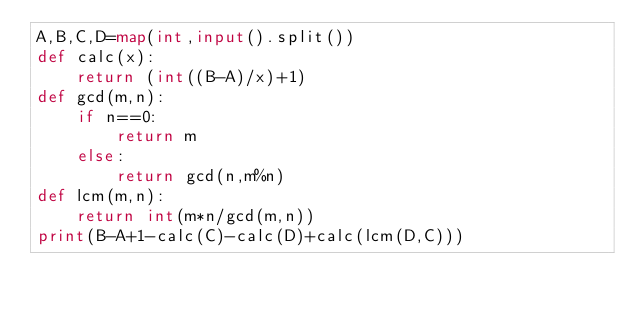Convert code to text. <code><loc_0><loc_0><loc_500><loc_500><_Python_>A,B,C,D=map(int,input().split())
def calc(x):
    return (int((B-A)/x)+1)
def gcd(m,n):
    if n==0:
        return m
    else:
        return gcd(n,m%n)
def lcm(m,n):
    return int(m*n/gcd(m,n))
print(B-A+1-calc(C)-calc(D)+calc(lcm(D,C)))</code> 